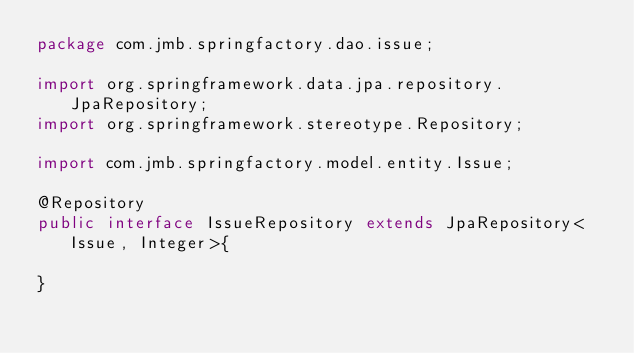Convert code to text. <code><loc_0><loc_0><loc_500><loc_500><_Java_>package com.jmb.springfactory.dao.issue;

import org.springframework.data.jpa.repository.JpaRepository;
import org.springframework.stereotype.Repository;

import com.jmb.springfactory.model.entity.Issue;

@Repository
public interface IssueRepository extends JpaRepository<Issue, Integer>{

}
</code> 